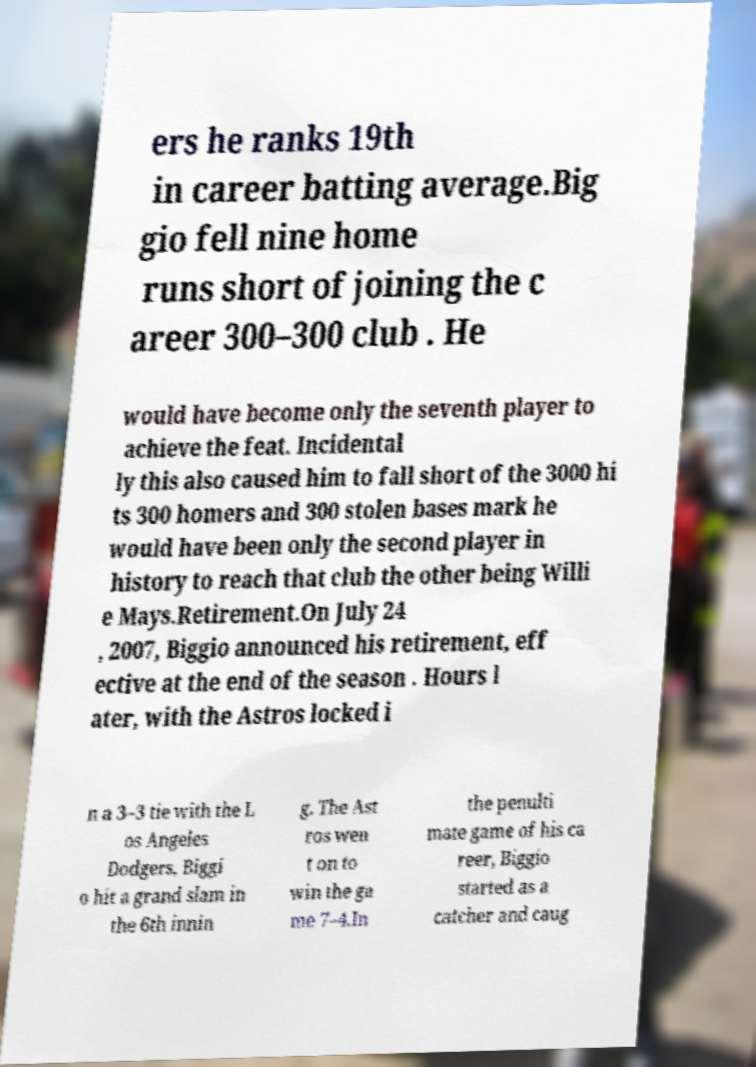Can you read and provide the text displayed in the image?This photo seems to have some interesting text. Can you extract and type it out for me? ers he ranks 19th in career batting average.Big gio fell nine home runs short of joining the c areer 300–300 club . He would have become only the seventh player to achieve the feat. Incidental ly this also caused him to fall short of the 3000 hi ts 300 homers and 300 stolen bases mark he would have been only the second player in history to reach that club the other being Willi e Mays.Retirement.On July 24 , 2007, Biggio announced his retirement, eff ective at the end of the season . Hours l ater, with the Astros locked i n a 3–3 tie with the L os Angeles Dodgers, Biggi o hit a grand slam in the 6th innin g. The Ast ros wen t on to win the ga me 7–4.In the penulti mate game of his ca reer, Biggio started as a catcher and caug 